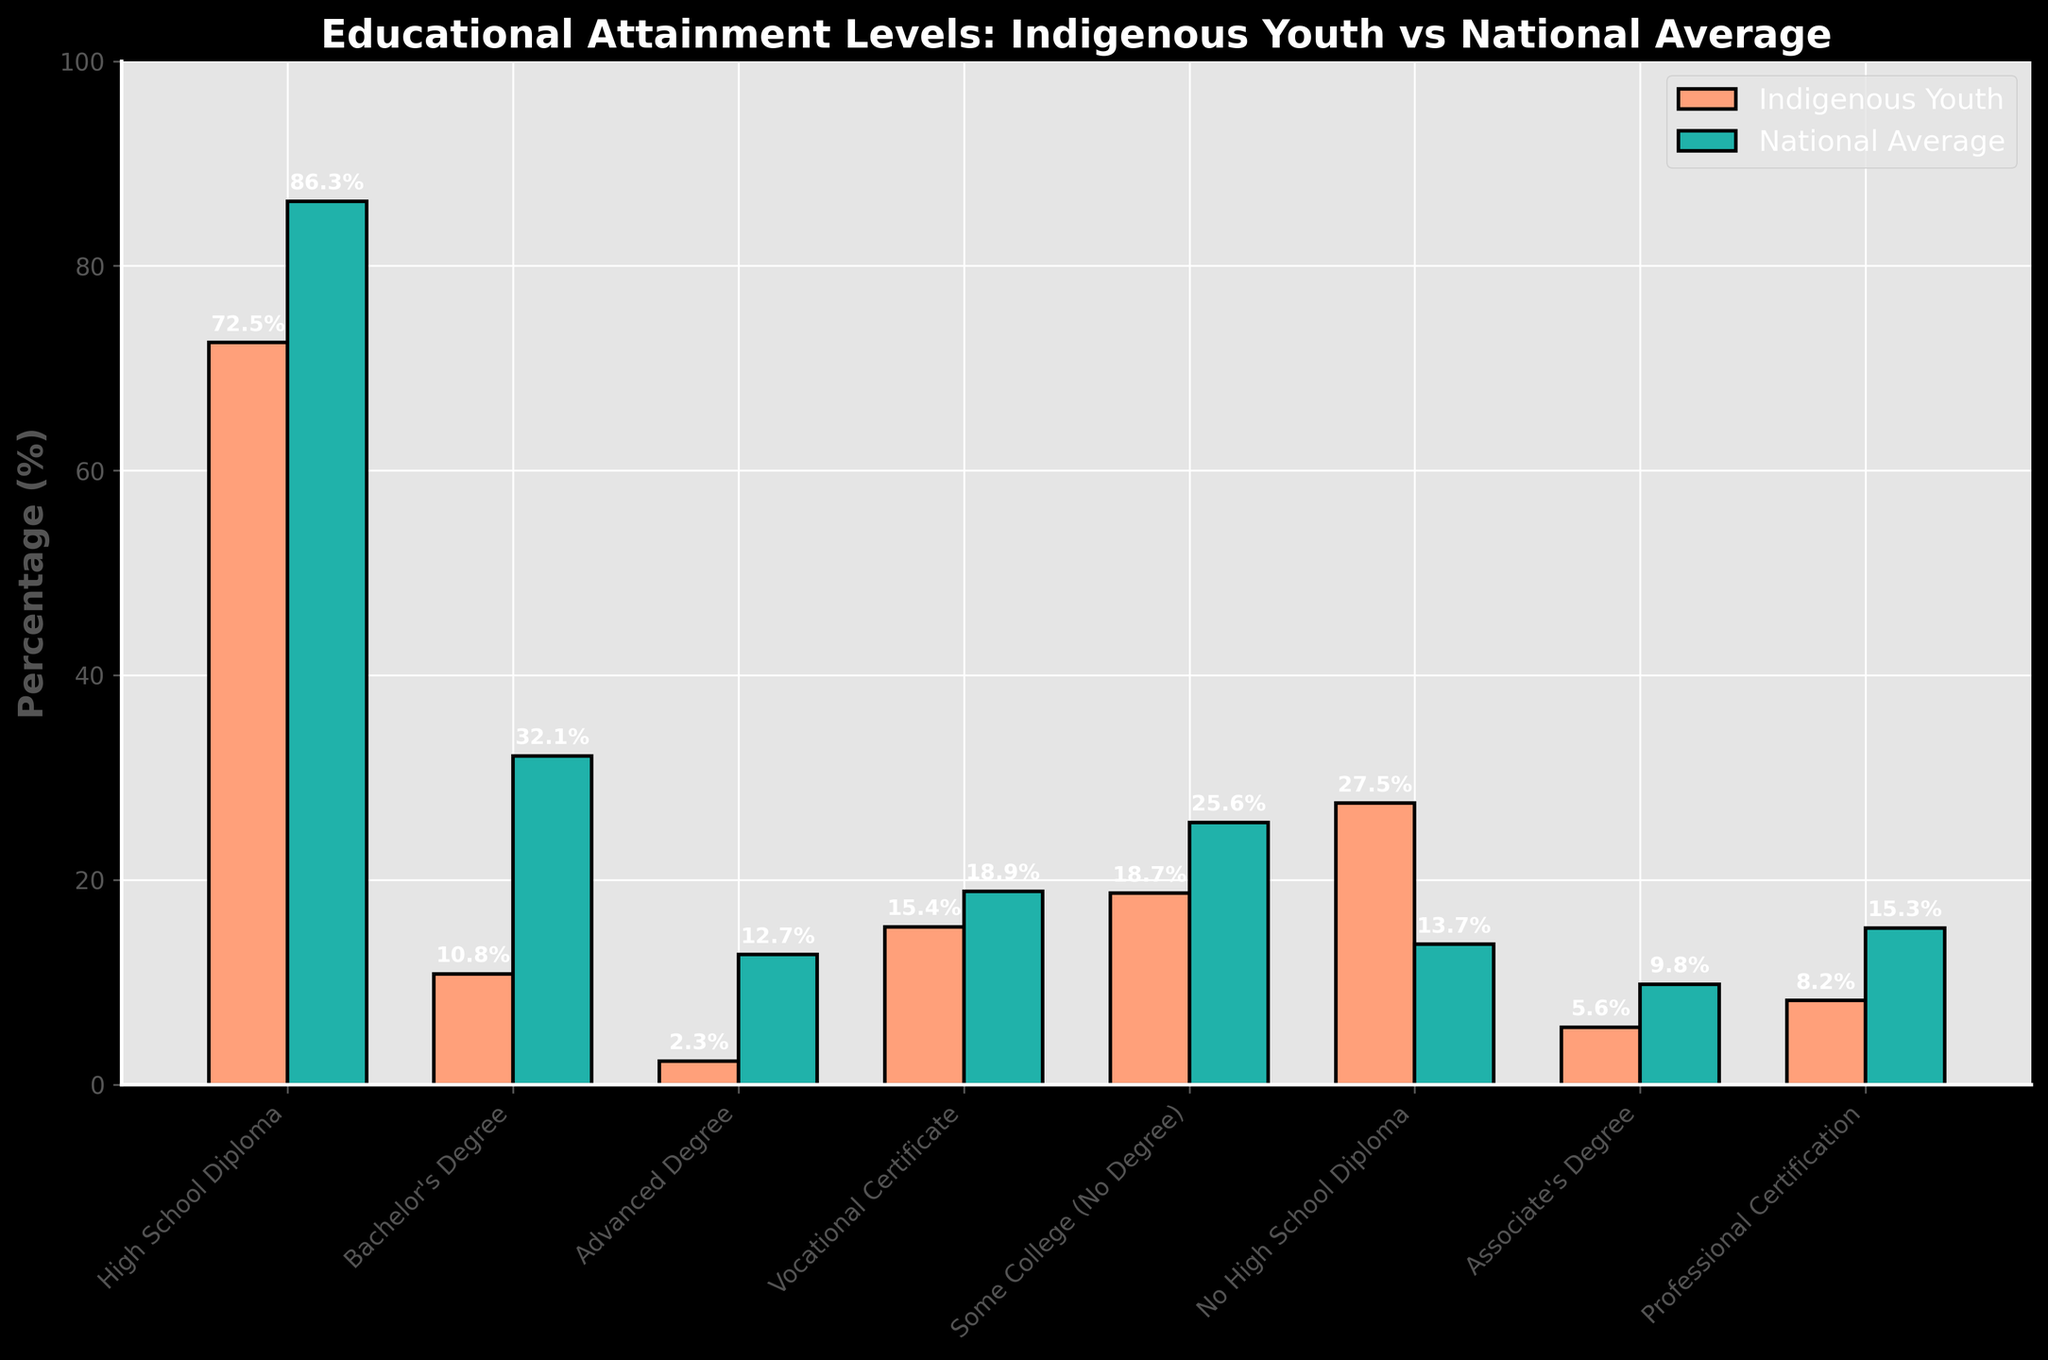what education level has the largest gap in percentage points between indigenous youth and the national average? To find the largest gap, we need to look at the difference between the percentages for each education level. The largest absolute difference is for the Bachelor's Degree, where the difference is 32.1% - 10.8% = 21.3 percentage points
Answer: Bachelor's Degree What is the total percentage of Indigenous youth with a High School Diploma or less? Sum the percentages of Indigenous youth with High School Diploma (72.5%) and No High School Diploma (27.5%) to get 72.5% + 27.5% = 100%
Answer: 100% Which education level shows the closest percentage between Indigenous youth and the national average? By comparing the differences, we find that the closest percentage is for the Vocational Certificate: The difference is 18.9% - 15.4% = 3.5 percentage points
Answer: Vocational Certificate How does the percentage of Indigenous youth without a high school diploma compare to the national average? Compare 27.5% (Indigenous youth) with 13.7% (national average). Indigenous youth have a higher percentage without a high school diploma
Answer: Higher What's the average percentage of Indigenous youth across all educational attainment levels? Sum all percentages and divide by the number of categories: (72.5 + 10.8 + 2.3 + 15.4 + 18.7 + 27.5 + 5.6 + 8.2) / 8 = 20.125%
Answer: 20.125% Which education levels show a higher percentage for the national average compared to Indigenous youth? Compare percentages for all education levels, and the national average is higher in all but "No High School Diploma"
Answer: All except "No High School Diploma" What percentage of Indigenous youth holds a professional certification? Directly read from the bar labeled "Professional Certification" in the Indigenous youth category: 8.2%
Answer: 8.2% Is the percentage of Indigenous youth with an advanced degree closer to those with a bachelor's degree or an associate's degree? Advanced Degree (2.3%) compared to Bachelor's Degree (10.8%) and Associate's Degree (5.6%). The difference with the Associate's Degree (3.3 percentage points) is smaller
Answer: Associate's Degree 